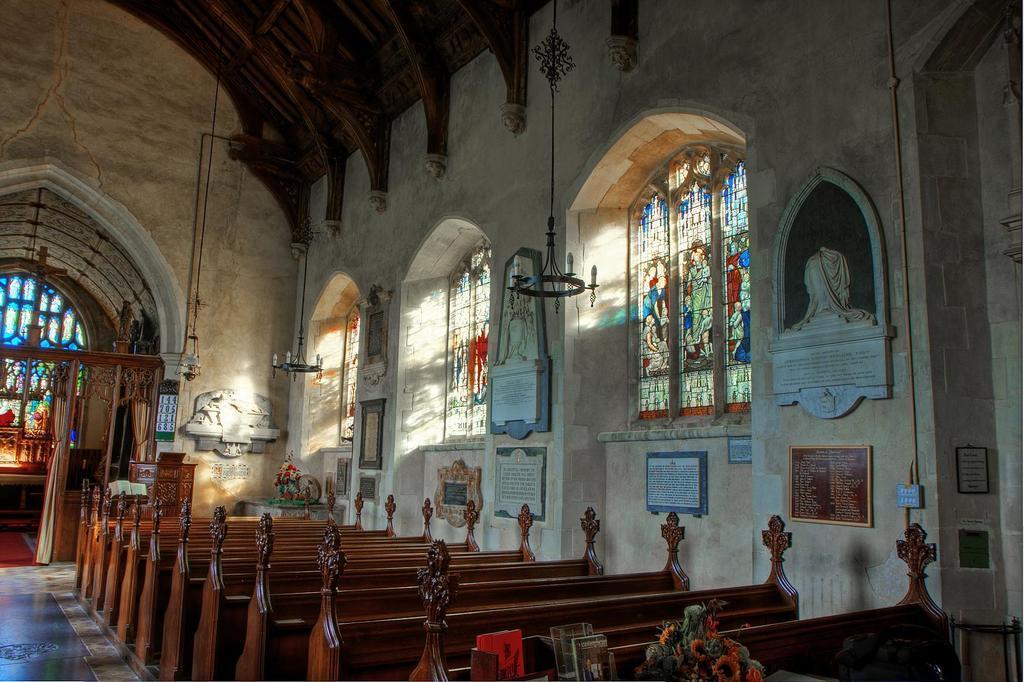Can you describe this image briefly? In this image, we can benches beside the wall. There are window in the middle of the image. 